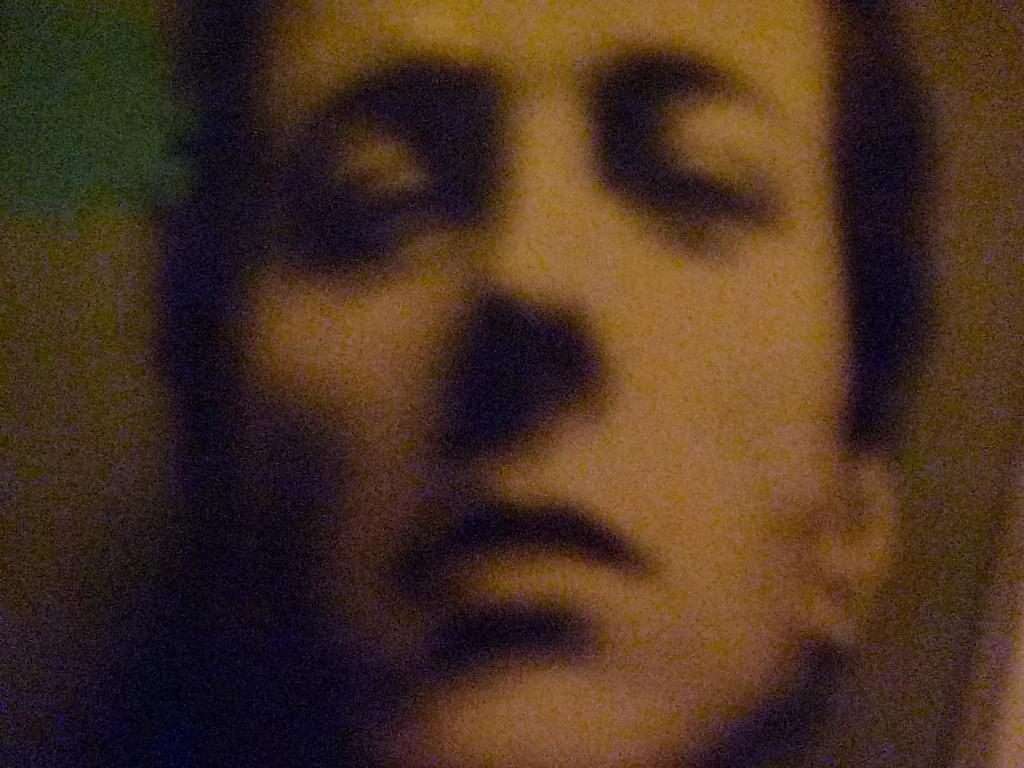What is the main subject of the image? There is a person's face in the image. Can you describe the background of the image? The background of the image is blurred. What type of authority is depicted in the image? There is no authority figure present in the image; it only features a person's face and a blurred background. What road conditions can be seen in the image? There is no road present in the image; it only features a person's face and a blurred background. 